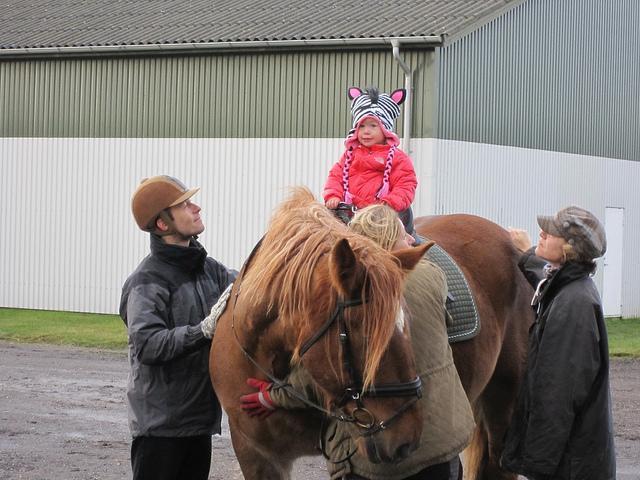How many kids are there?
Give a very brief answer. 1. How many people are in the photo?
Give a very brief answer. 3. How many horses are visible?
Give a very brief answer. 1. How many dogs are wearing a leash?
Give a very brief answer. 0. 